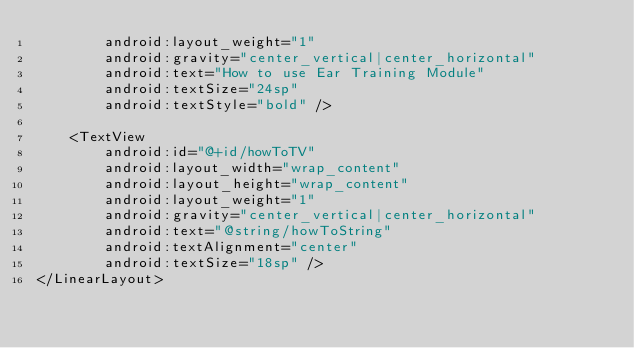<code> <loc_0><loc_0><loc_500><loc_500><_XML_>        android:layout_weight="1"
        android:gravity="center_vertical|center_horizontal"
        android:text="How to use Ear Training Module"
        android:textSize="24sp"
        android:textStyle="bold" />

    <TextView
        android:id="@+id/howToTV"
        android:layout_width="wrap_content"
        android:layout_height="wrap_content"
        android:layout_weight="1"
        android:gravity="center_vertical|center_horizontal"
        android:text="@string/howToString"
        android:textAlignment="center"
        android:textSize="18sp" />
</LinearLayout>
</code> 